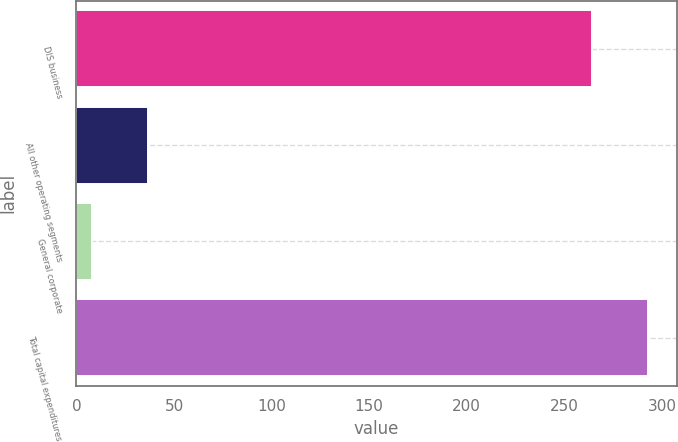<chart> <loc_0><loc_0><loc_500><loc_500><bar_chart><fcel>DIS business<fcel>All other operating segments<fcel>General corporate<fcel>Total capital expenditures<nl><fcel>264<fcel>36.5<fcel>8<fcel>293<nl></chart> 